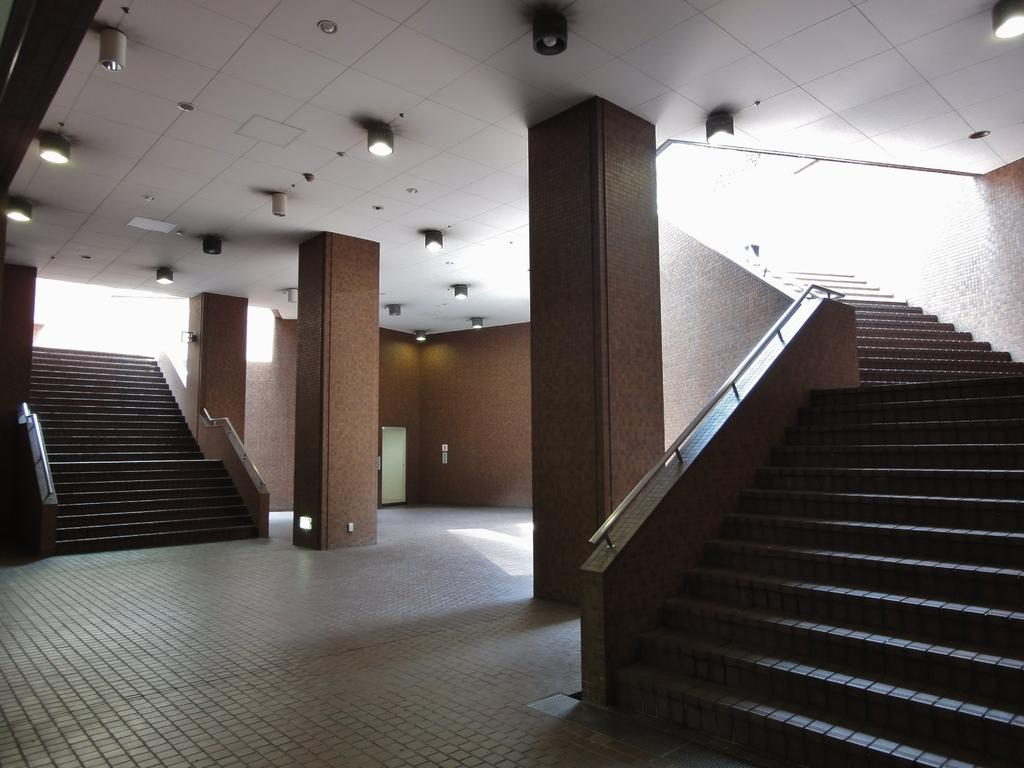What type of location is depicted in the image? The image shows an inside view of a building. How many staircases can be seen in the image? There are two staircases in the image. What material are the rods made of in the image? Metal rods are visible in the image. What are the poles used for in the image? The poles are present in the image, but their specific purpose is not clear from the provided facts. What is used for illumination in the image? There are lights in the image. What type of stew is being cooked on the heat source in the image? There is no heat source or stew present in the image. 